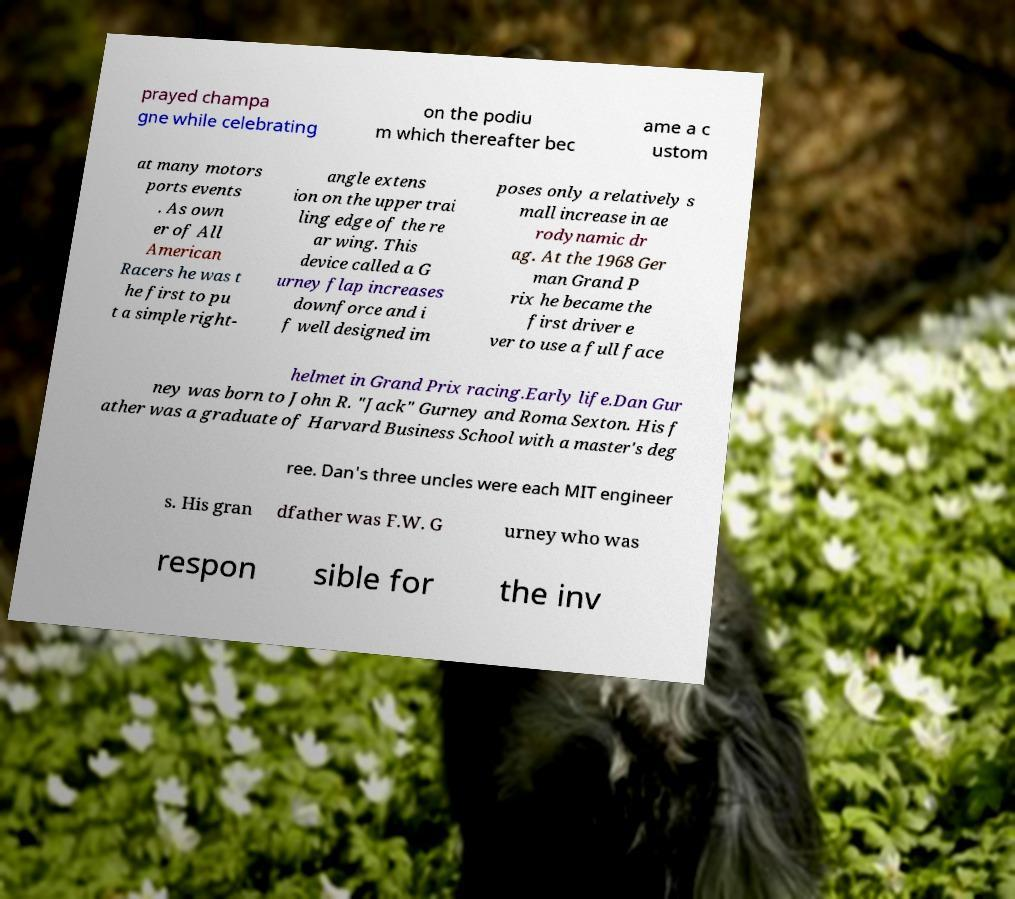Please read and relay the text visible in this image. What does it say? prayed champa gne while celebrating on the podiu m which thereafter bec ame a c ustom at many motors ports events . As own er of All American Racers he was t he first to pu t a simple right- angle extens ion on the upper trai ling edge of the re ar wing. This device called a G urney flap increases downforce and i f well designed im poses only a relatively s mall increase in ae rodynamic dr ag. At the 1968 Ger man Grand P rix he became the first driver e ver to use a full face helmet in Grand Prix racing.Early life.Dan Gur ney was born to John R. "Jack" Gurney and Roma Sexton. His f ather was a graduate of Harvard Business School with a master's deg ree. Dan's three uncles were each MIT engineer s. His gran dfather was F.W. G urney who was respon sible for the inv 